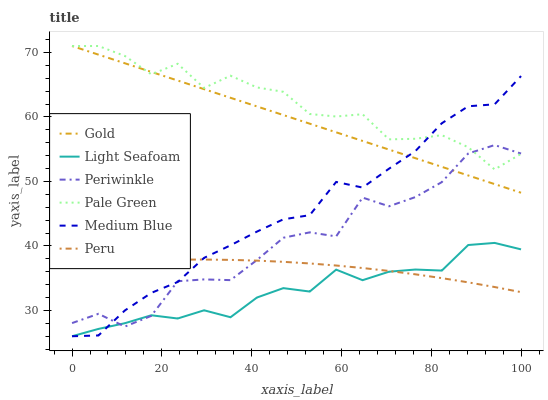Does Light Seafoam have the minimum area under the curve?
Answer yes or no. Yes. Does Pale Green have the maximum area under the curve?
Answer yes or no. Yes. Does Medium Blue have the minimum area under the curve?
Answer yes or no. No. Does Medium Blue have the maximum area under the curve?
Answer yes or no. No. Is Gold the smoothest?
Answer yes or no. Yes. Is Periwinkle the roughest?
Answer yes or no. Yes. Is Medium Blue the smoothest?
Answer yes or no. No. Is Medium Blue the roughest?
Answer yes or no. No. Does Medium Blue have the lowest value?
Answer yes or no. Yes. Does Pale Green have the lowest value?
Answer yes or no. No. Does Pale Green have the highest value?
Answer yes or no. Yes. Does Medium Blue have the highest value?
Answer yes or no. No. Is Light Seafoam less than Gold?
Answer yes or no. Yes. Is Pale Green greater than Peru?
Answer yes or no. Yes. Does Light Seafoam intersect Peru?
Answer yes or no. Yes. Is Light Seafoam less than Peru?
Answer yes or no. No. Is Light Seafoam greater than Peru?
Answer yes or no. No. Does Light Seafoam intersect Gold?
Answer yes or no. No. 